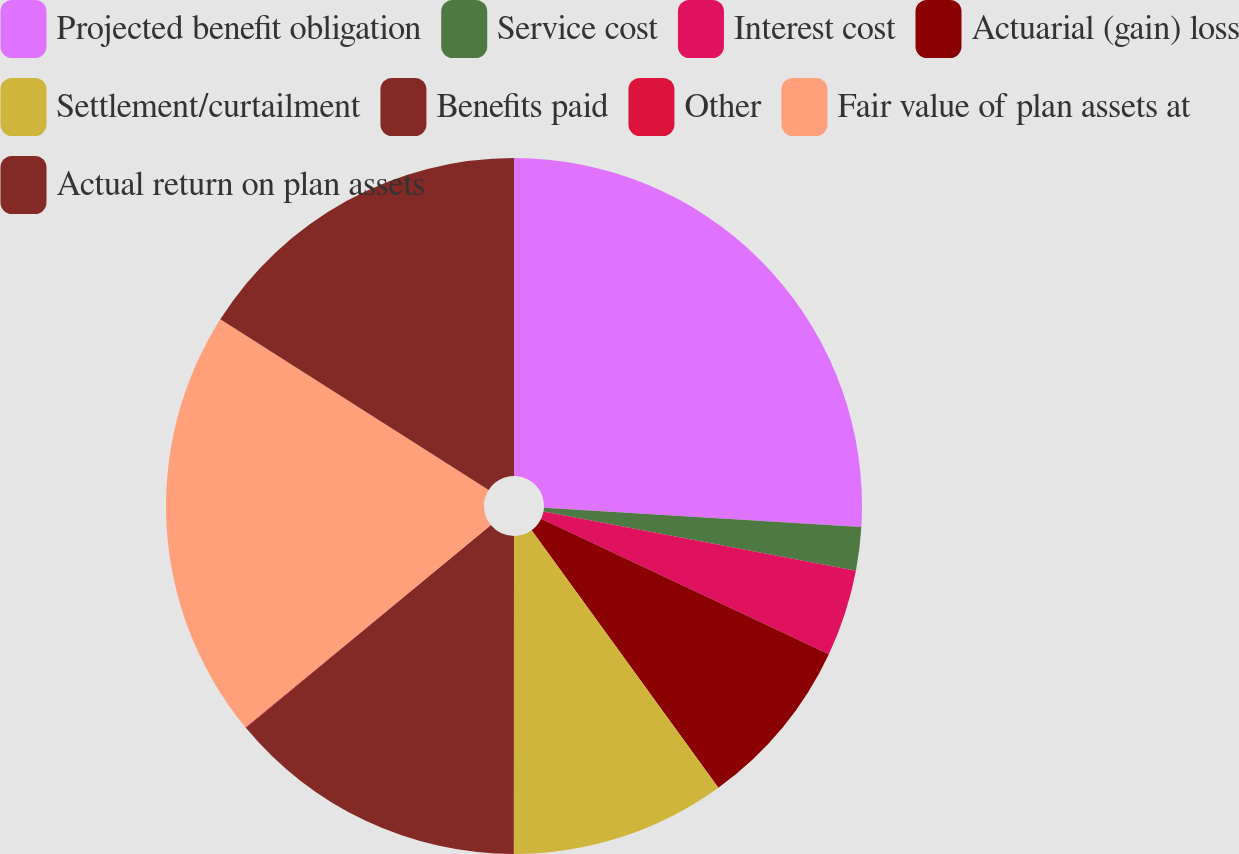Convert chart. <chart><loc_0><loc_0><loc_500><loc_500><pie_chart><fcel>Projected benefit obligation<fcel>Service cost<fcel>Interest cost<fcel>Actuarial (gain) loss<fcel>Settlement/curtailment<fcel>Benefits paid<fcel>Other<fcel>Fair value of plan assets at<fcel>Actual return on plan assets<nl><fcel>25.96%<fcel>2.02%<fcel>4.02%<fcel>8.01%<fcel>10.0%<fcel>13.99%<fcel>0.03%<fcel>19.98%<fcel>15.99%<nl></chart> 